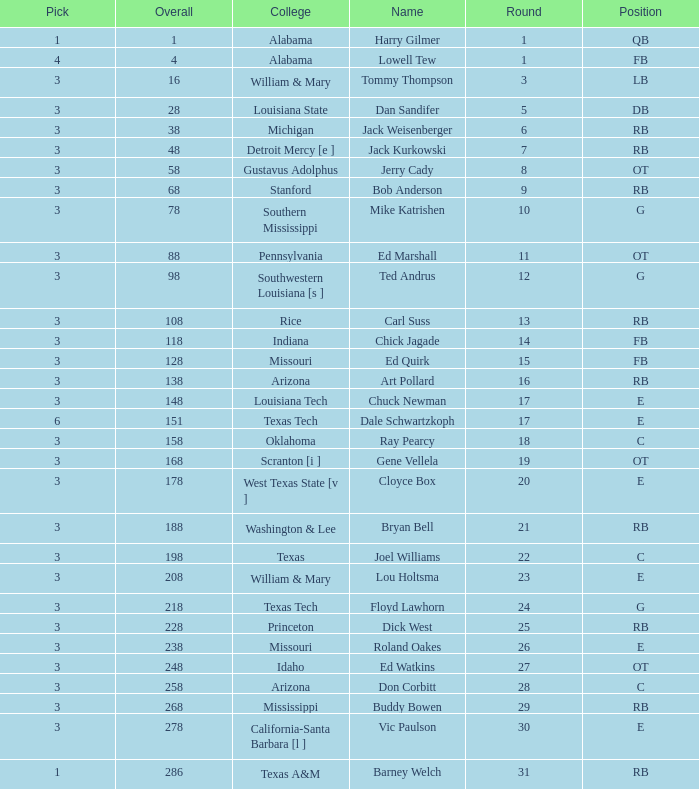How much Overall has a Name of bob anderson? 1.0. 